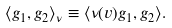Convert formula to latex. <formula><loc_0><loc_0><loc_500><loc_500>\langle g _ { 1 } , g _ { 2 } \rangle _ { \nu } \equiv \langle \nu ( v ) g _ { 1 } , g _ { 2 } \rangle .</formula> 